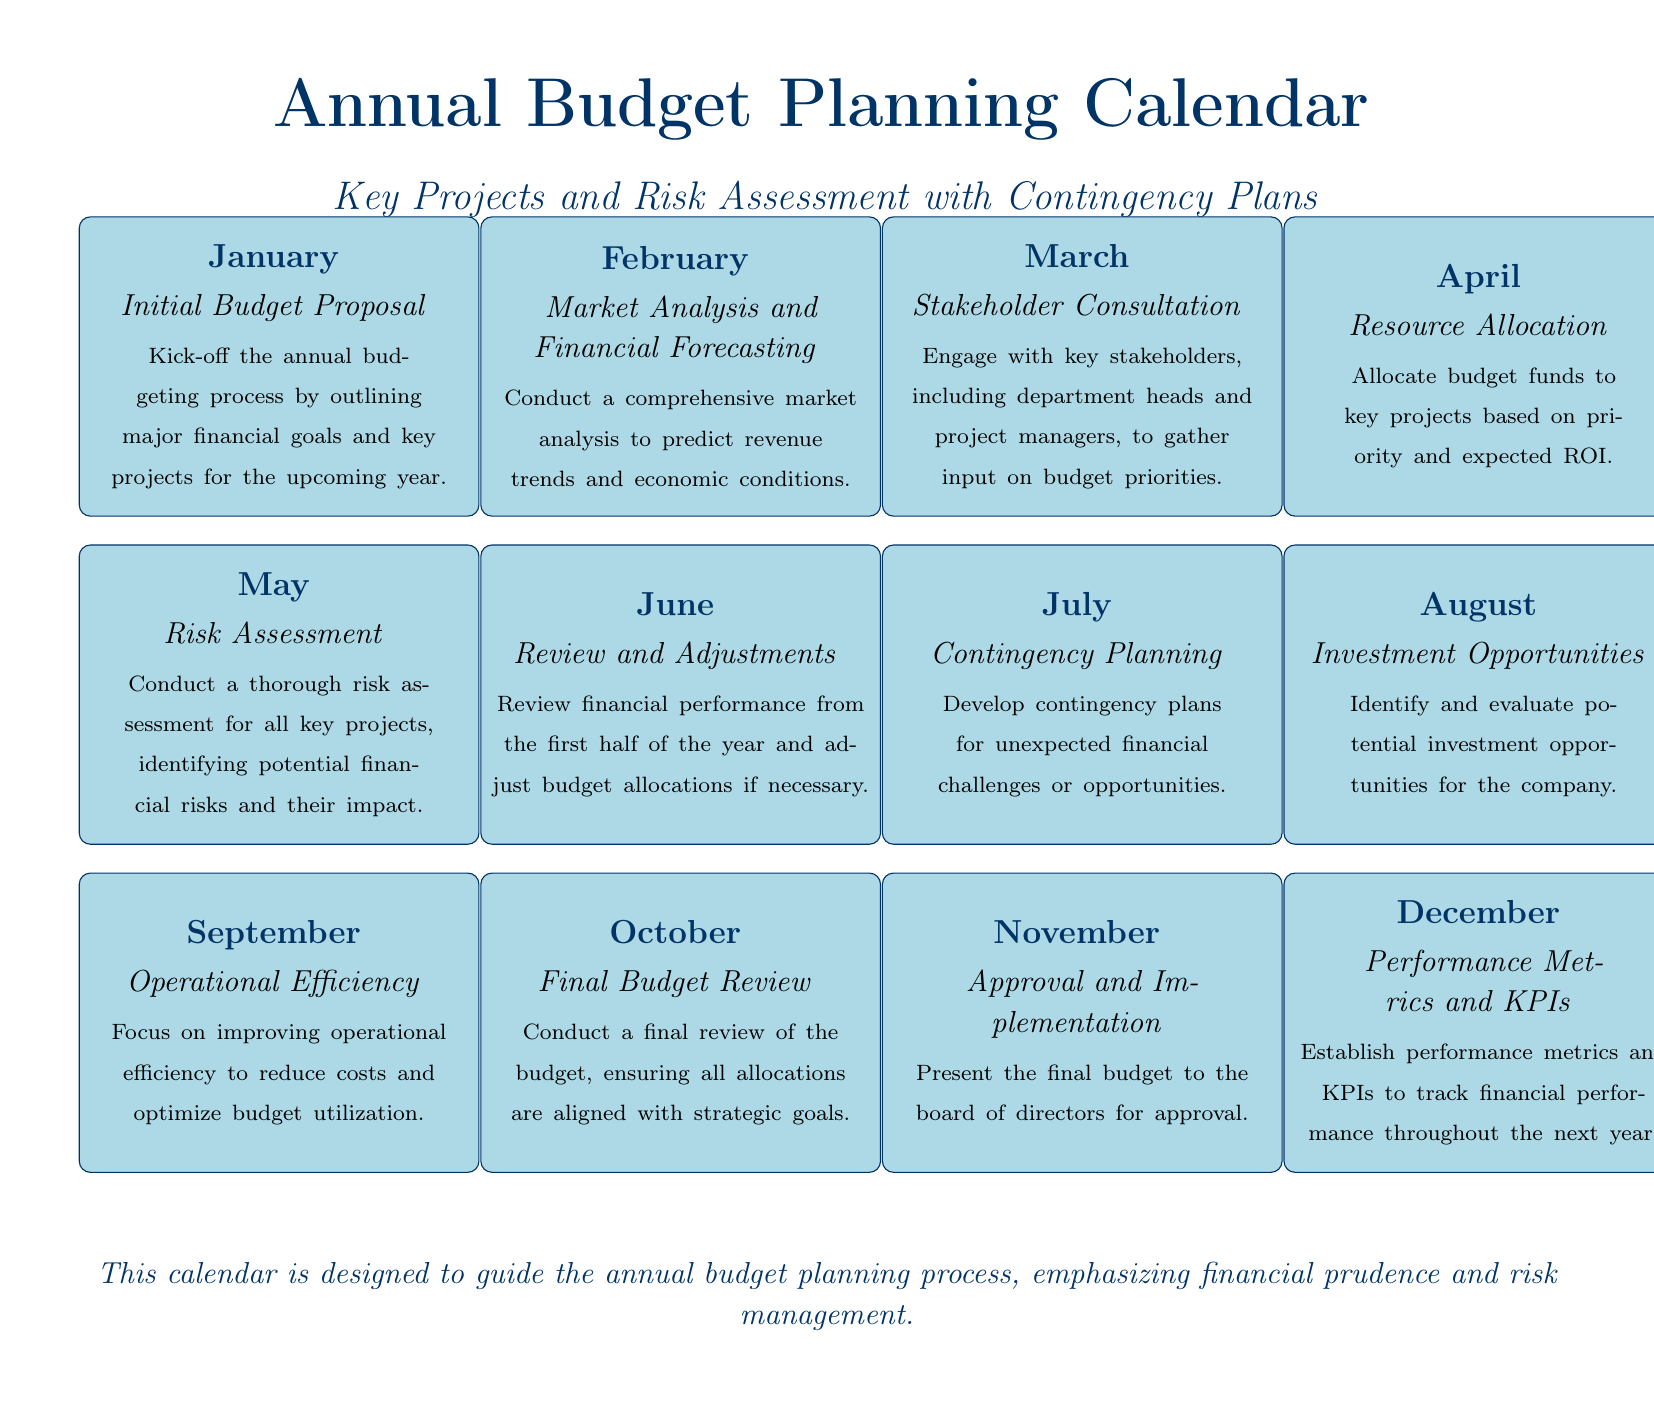What is the main focus of the calendar? The main focus of the calendar is on annual budget planning, specifically regarding key projects and risk assessment with contingency plans.
Answer: Annual Budget Planning Which month involves risk assessment? Risk assessment is scheduled for May, highlighting its importance in the budget planning process.
Answer: May What activity is planned for October? In October, the final budget review is conducted to ensure all allocations align with strategic goals.
Answer: Final Budget Review How many key projects does the calendar outline? The calendar outlines a total of 12 key activities over 12 months, each addressing different aspects of budget planning.
Answer: 12 What is the purpose of stakeholder consultation? Stakeholder consultation in March aims to gather input on budget priorities from key stakeholders, enhancing collaborative decision-making.
Answer: Budget priorities Which month is designated for contingency planning? Contingency planning is scheduled for July, focusing on developing plans for unexpected financial challenges.
Answer: July What is the timeframe of the annual budget planning process outlined in the calendar? The timeframe spans the entire year, from January to December, with each month dedicated to a specific budgeting task.
Answer: One year What performance metrics are established in December? The performance metrics and KPIs are established to track financial performance throughout the next year, ensuring accountability and measurement.
Answer: KPIs 